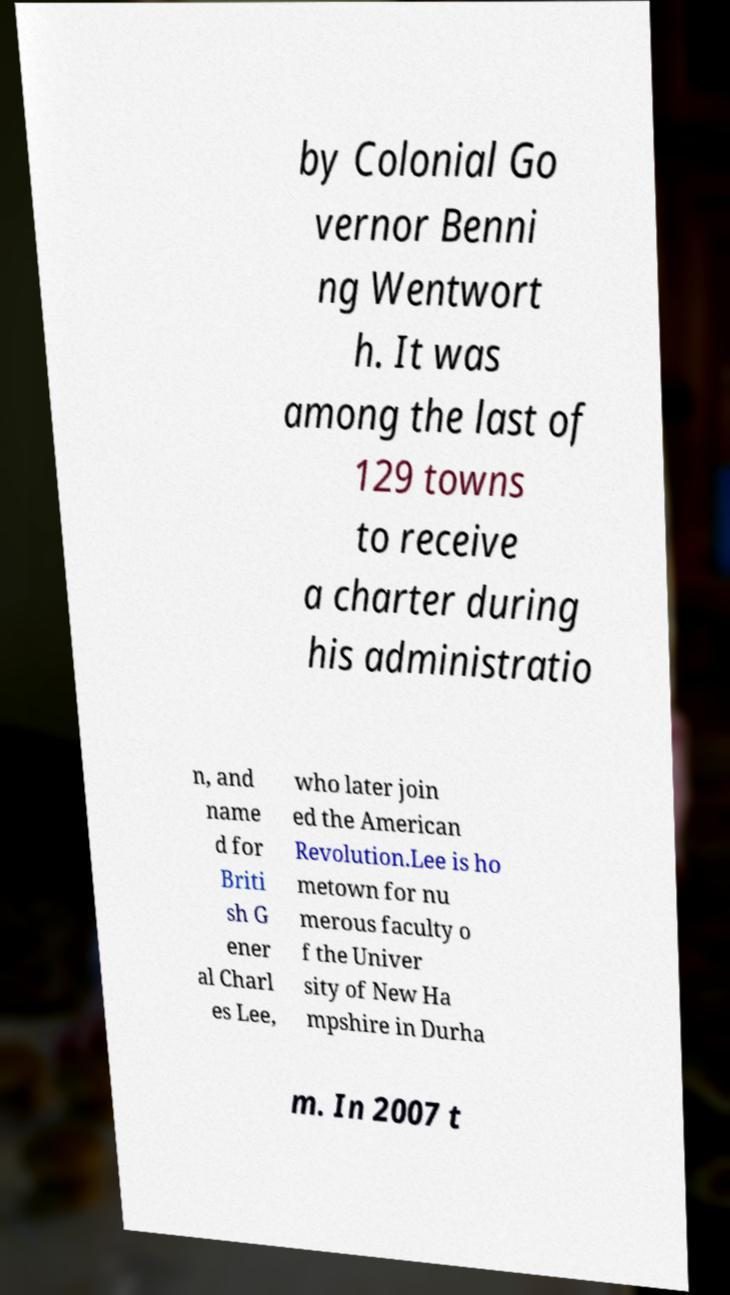Could you assist in decoding the text presented in this image and type it out clearly? by Colonial Go vernor Benni ng Wentwort h. It was among the last of 129 towns to receive a charter during his administratio n, and name d for Briti sh G ener al Charl es Lee, who later join ed the American Revolution.Lee is ho metown for nu merous faculty o f the Univer sity of New Ha mpshire in Durha m. In 2007 t 